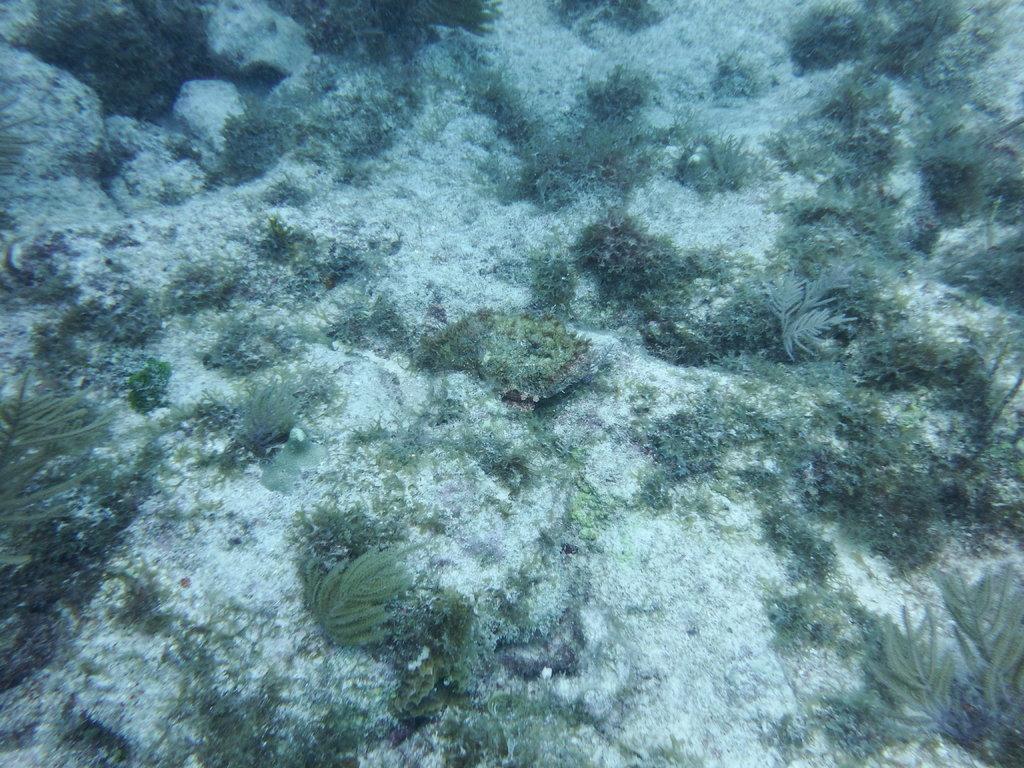Please provide a concise description of this image. In the foreground of this image, there are grass and plants under the water. 